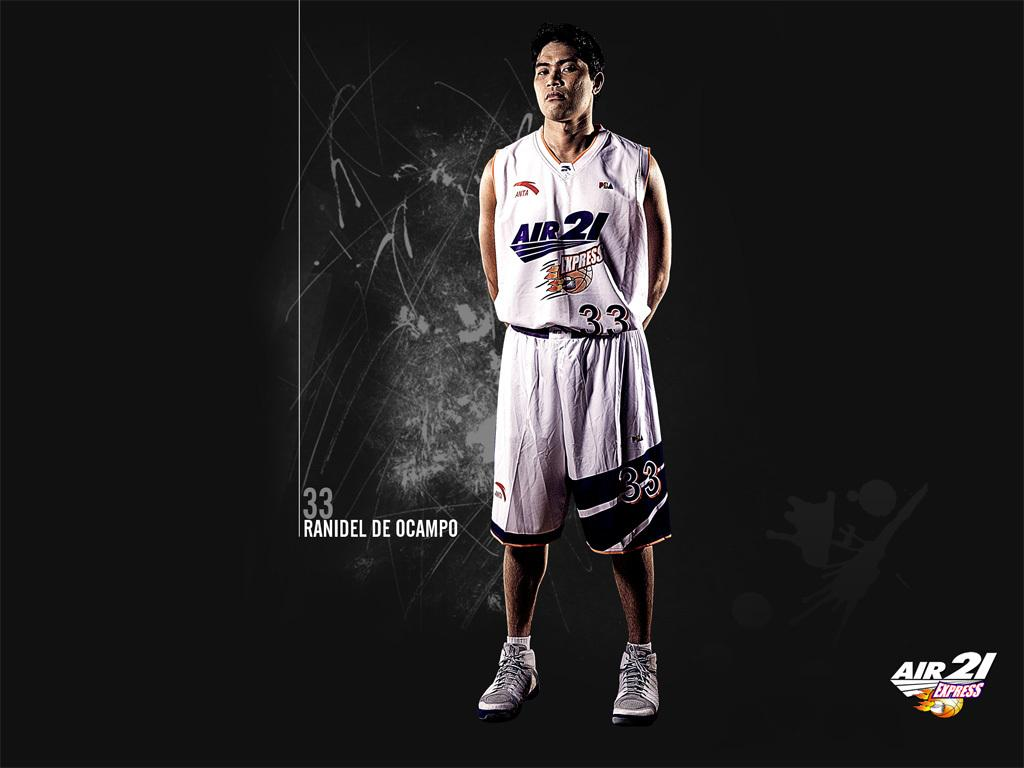<image>
Summarize the visual content of the image. Player number 33 is named Ranidel De Ocampo. 